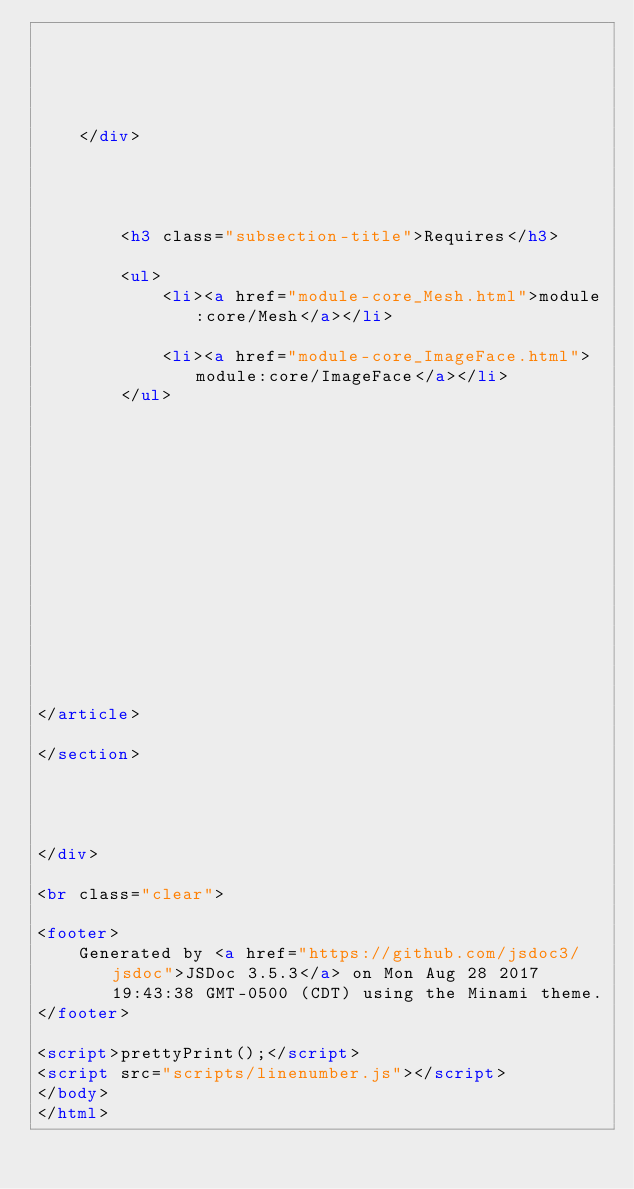Convert code to text. <code><loc_0><loc_0><loc_500><loc_500><_HTML_>    
        

        
    
    </div>

    

    
        <h3 class="subsection-title">Requires</h3>

        <ul>
            <li><a href="module-core_Mesh.html">module:core/Mesh</a></li>
        
            <li><a href="module-core_ImageFace.html">module:core/ImageFace</a></li>
        </ul>
    

    

     

    

    

    

    

    
</article>

</section>




</div>

<br class="clear">

<footer>
    Generated by <a href="https://github.com/jsdoc3/jsdoc">JSDoc 3.5.3</a> on Mon Aug 28 2017 19:43:38 GMT-0500 (CDT) using the Minami theme.
</footer>

<script>prettyPrint();</script>
<script src="scripts/linenumber.js"></script>
</body>
</html></code> 